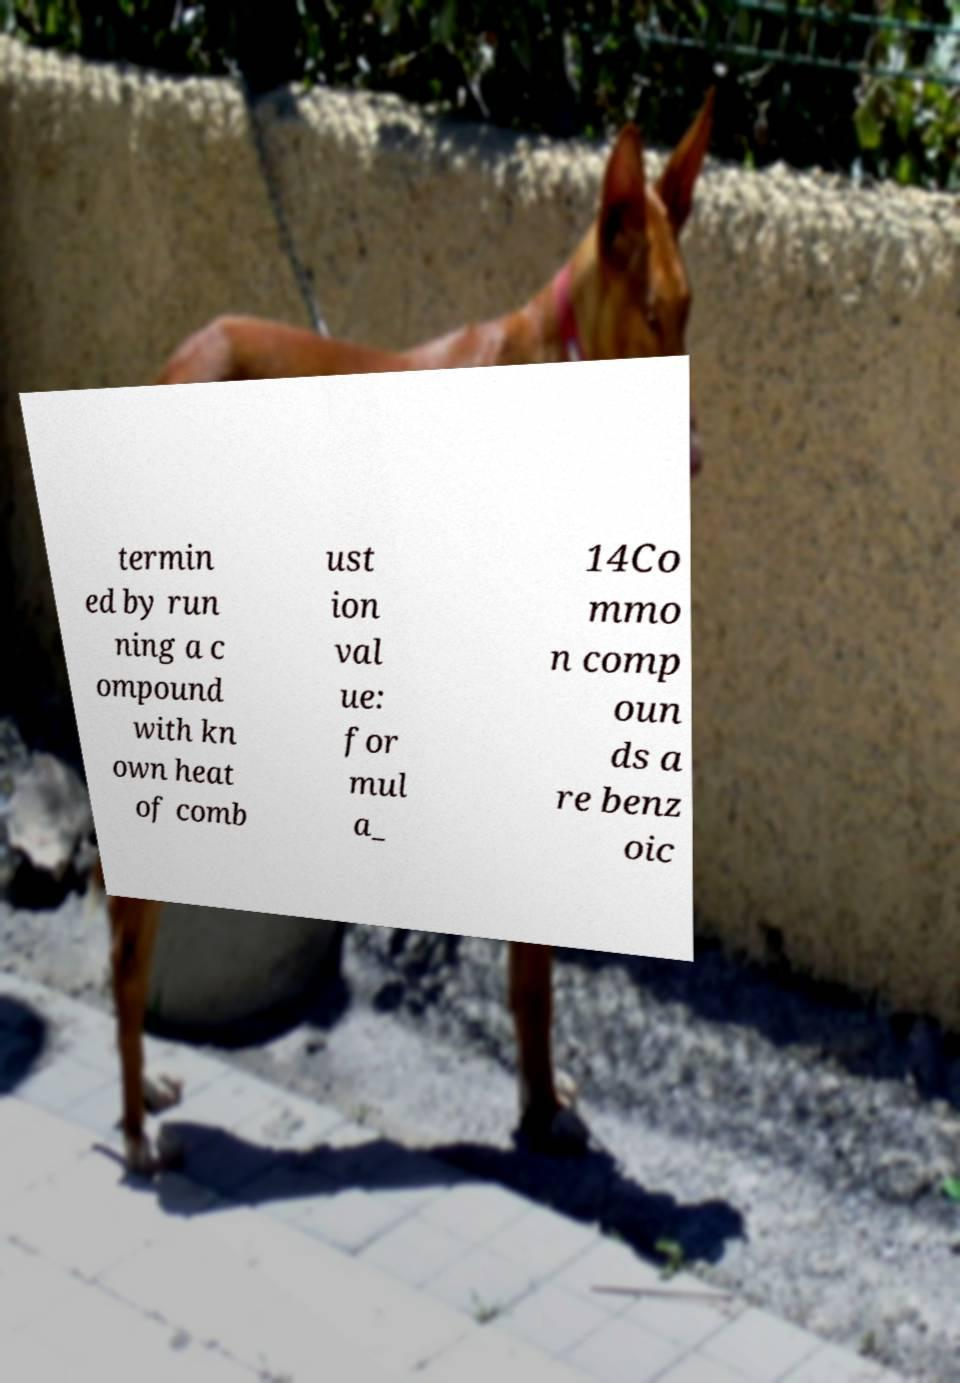There's text embedded in this image that I need extracted. Can you transcribe it verbatim? termin ed by run ning a c ompound with kn own heat of comb ust ion val ue: for mul a_ 14Co mmo n comp oun ds a re benz oic 